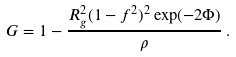Convert formula to latex. <formula><loc_0><loc_0><loc_500><loc_500>G = 1 - \frac { R _ { g } ^ { 2 } ( 1 - f ^ { 2 } ) ^ { 2 } \exp ( - 2 \Phi ) } { \rho } \, .</formula> 